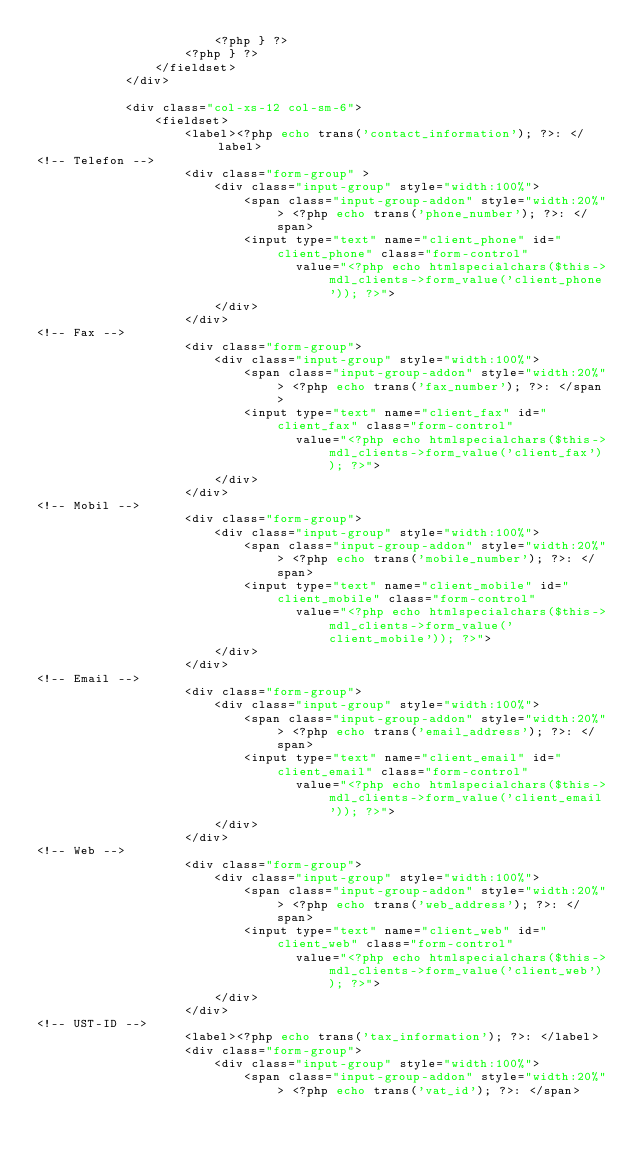<code> <loc_0><loc_0><loc_500><loc_500><_PHP_>                        <?php } ?>
                    <?php } ?>
                </fieldset>
            </div>

            <div class="col-xs-12 col-sm-6">
                <fieldset>
                    <label><?php echo trans('contact_information'); ?>: </label>
<!-- Telefon -->
                    <div class="form-group" >                       
                        <div class="input-group" style="width:100%">
                            <span class="input-group-addon" style="width:20%"> <?php echo trans('phone_number'); ?>: </span>
                            <input type="text" name="client_phone" id="client_phone" class="form-control"
                                   value="<?php echo htmlspecialchars($this->mdl_clients->form_value('client_phone')); ?>">
                        </div>
                    </div>
<!-- Fax -->
                    <div class="form-group">
                        <div class="input-group" style="width:100%">
                            <span class="input-group-addon" style="width:20%"> <?php echo trans('fax_number'); ?>: </span>
                            <input type="text" name="client_fax" id="client_fax" class="form-control"
                                   value="<?php echo htmlspecialchars($this->mdl_clients->form_value('client_fax')); ?>">
                        </div>
                    </div>
<!-- Mobil -->
                    <div class="form-group">
                        <div class="input-group" style="width:100%">
                            <span class="input-group-addon" style="width:20%"> <?php echo trans('mobile_number'); ?>: </span>
                            <input type="text" name="client_mobile" id="client_mobile" class="form-control"
                                   value="<?php echo htmlspecialchars($this->mdl_clients->form_value('client_mobile')); ?>">
                        </div>
                    </div>
<!-- Email -->
                    <div class="form-group">
                        <div class="input-group" style="width:100%">
                            <span class="input-group-addon" style="width:20%"> <?php echo trans('email_address'); ?>: </span>
                            <input type="text" name="client_email" id="client_email" class="form-control"
                                   value="<?php echo htmlspecialchars($this->mdl_clients->form_value('client_email')); ?>">
                        </div>
                    </div>
<!-- Web -->
                    <div class="form-group">
                        <div class="input-group" style="width:100%">
                            <span class="input-group-addon" style="width:20%"> <?php echo trans('web_address'); ?>: </span>
                            <input type="text" name="client_web" id="client_web" class="form-control"
                                   value="<?php echo htmlspecialchars($this->mdl_clients->form_value('client_web')); ?>">
                        </div>
                    </div>
<!-- UST-ID -->
                    <label><?php echo trans('tax_information'); ?>: </label>
                    <div class="form-group">
                        <div class="input-group" style="width:100%">
                            <span class="input-group-addon" style="width:20%"> <?php echo trans('vat_id'); ?>: </span></code> 